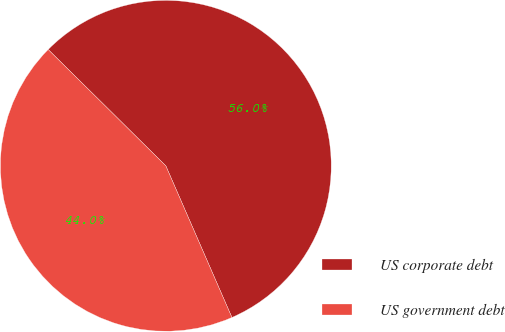<chart> <loc_0><loc_0><loc_500><loc_500><pie_chart><fcel>US corporate debt<fcel>US government debt<nl><fcel>56.05%<fcel>43.95%<nl></chart> 